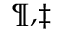Convert formula to latex. <formula><loc_0><loc_0><loc_500><loc_500>^ { \ m a t h p a r a g r a p h , \ddagger }</formula> 